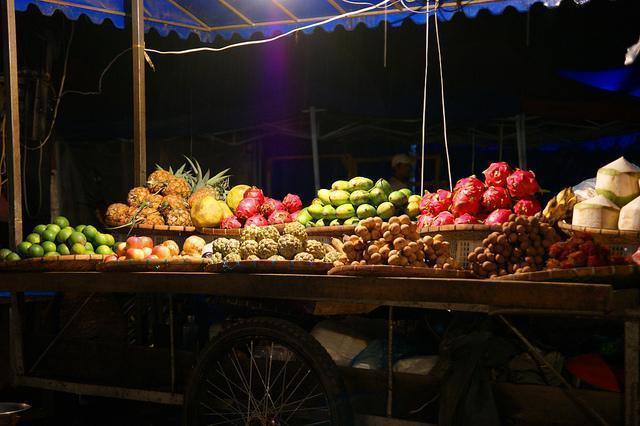What would you call this type of fruit seller?
Select the accurate response from the four choices given to answer the question.
Options: Retailer, merchant, grocer, street vendor. Street vendor. 